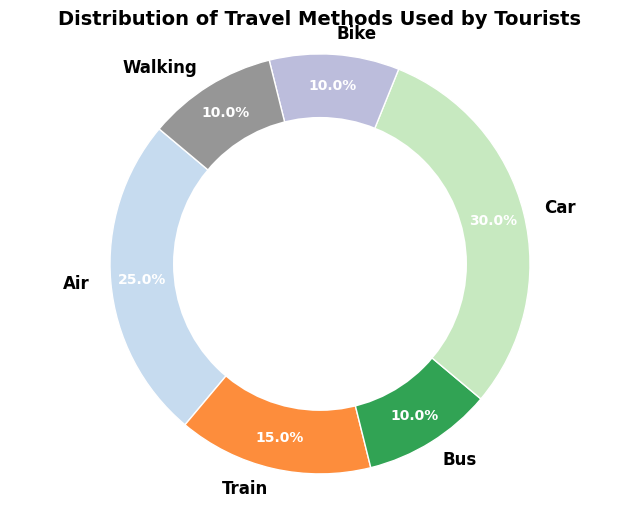Which travel method is used the most? The pie chart shows that the 'Car' segment takes up the largest portion, indicating it is the most used travel method by tourists with 30%.
Answer: Car What percentage of tourists travel by Air? According to the pie chart, the 'Air' segment is labeled with 25%.
Answer: 25% Which travel methods share the same percentage of usage? The pie chart shows that 'Bus', 'Bike', and 'Walking' each have a 10% share.
Answer: Bus, Bike, Walking Is the usage of Trains greater than Buses? The 'Train' segment covers 15%, while the 'Bus' segment covers 10%, so Train usage is greater.
Answer: Yes What is the combined percentage of tourists using Bike and Walking? Both 'Bike' and 'Walking' have 10%, adding them together yields 10% + 10% = 20%.
Answer: 20% How much larger is the percentage of car users compared to train users? 'Car' users account for 30% and 'Train' users account for 15%. The difference is 30% - 15% = 15%.
Answer: 15% Which travel method is the least used and how many methods share this percentage? The least used methods are 'Bus', 'Bike', and 'Walking', each with 10%.
Answer: Bus, Bike, Walking (three methods) What is the difference in percentage between the most used and the least used travel methods? The most used method is 'Car' with 30%, and the least used methods ('Bus', 'Bike', 'Walking') each have 10%. The difference is 30% - 10% = 20%.
Answer: 20% What percentage of tourists travels by sustainable methods (Bike and Walking)? Both 'Bike' and 'Walking' each have 10%, so the combined percentage is 10% + 10% = 20%.
Answer: 20% 